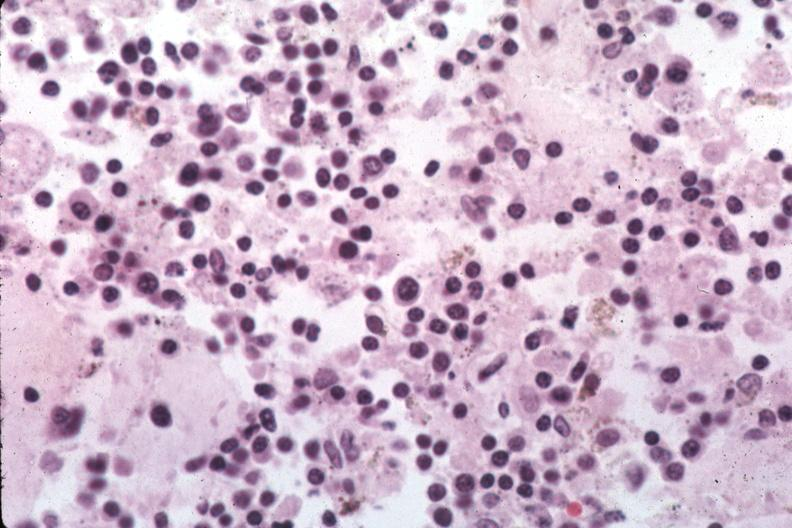s postpartum present?
Answer the question using a single word or phrase. No 